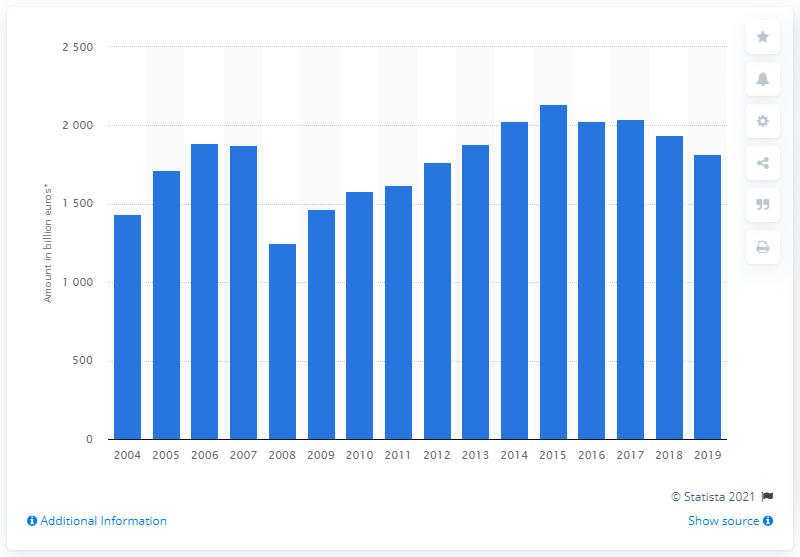Draw attention to some important aspects in this diagram. The total investment portfolio of all insurance companies in the UK in 2011 was 1620.52. In 2015, the highest value of investments on the domestic market in the UK was 2,138.59. The total investment portfolio of all insurance companies in the UK in 2019 was £181.83 billion. 